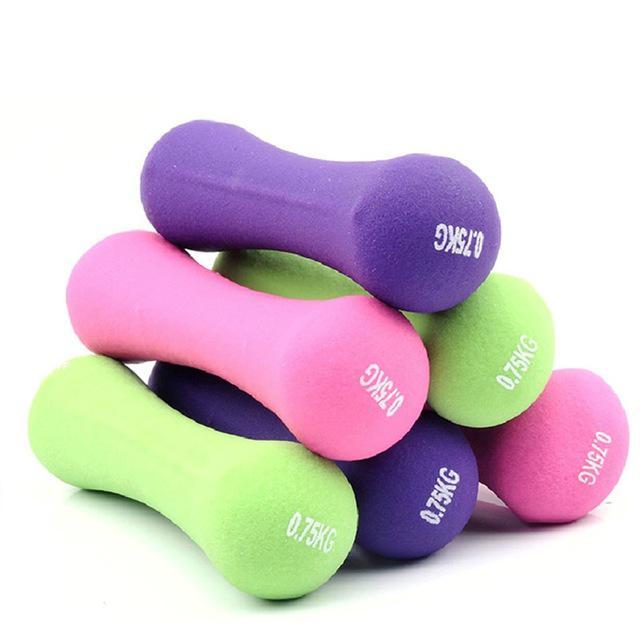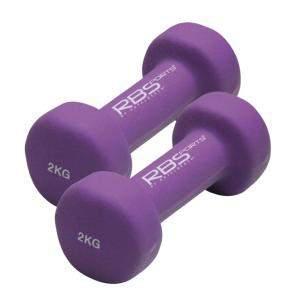The first image is the image on the left, the second image is the image on the right. For the images shown, is this caption "One image contains two each of three different colors of barbell-shaped weights." true? Answer yes or no. Yes. The first image is the image on the left, the second image is the image on the right. Assess this claim about the two images: "The left and right image contains the a total of eight weights.". Correct or not? Answer yes or no. Yes. 